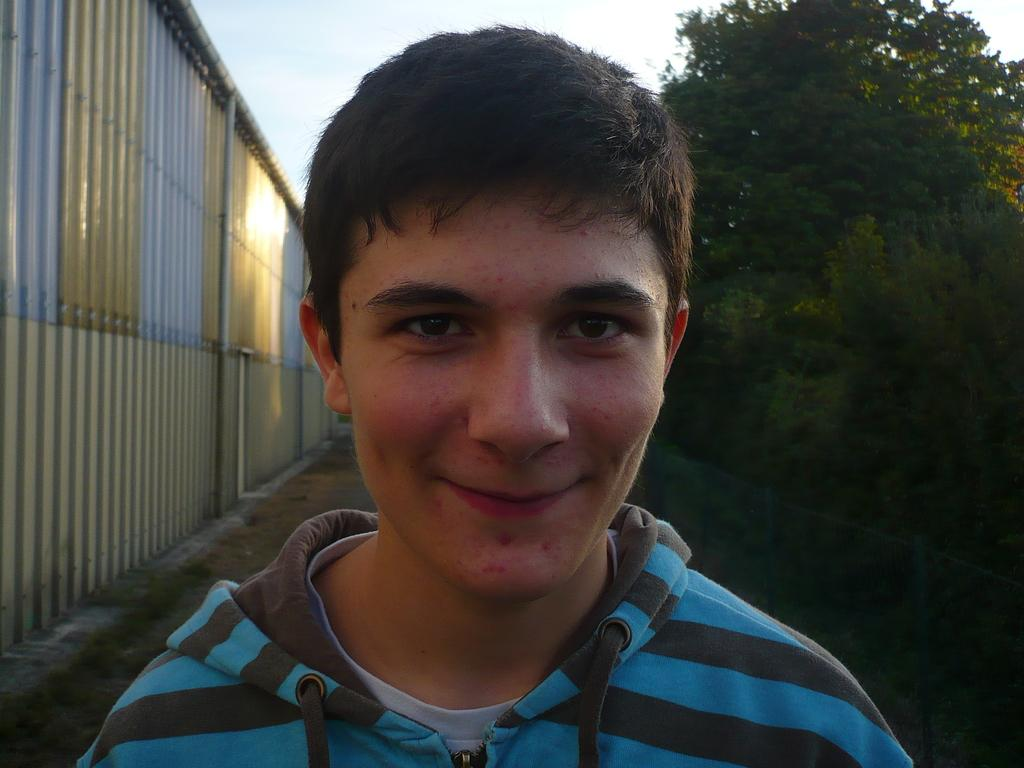Who is present in the image? There is a man in the image. What is the man's facial expression? The man is smiling. What can be seen in the background of the image? There are trees, a wall, and the sky visible in the background of the image. What type of soda is the man holding in the image? There is no soda present in the image; the man is not holding any object. Can you see any bubbles in the image? There are no bubbles visible in the image. 